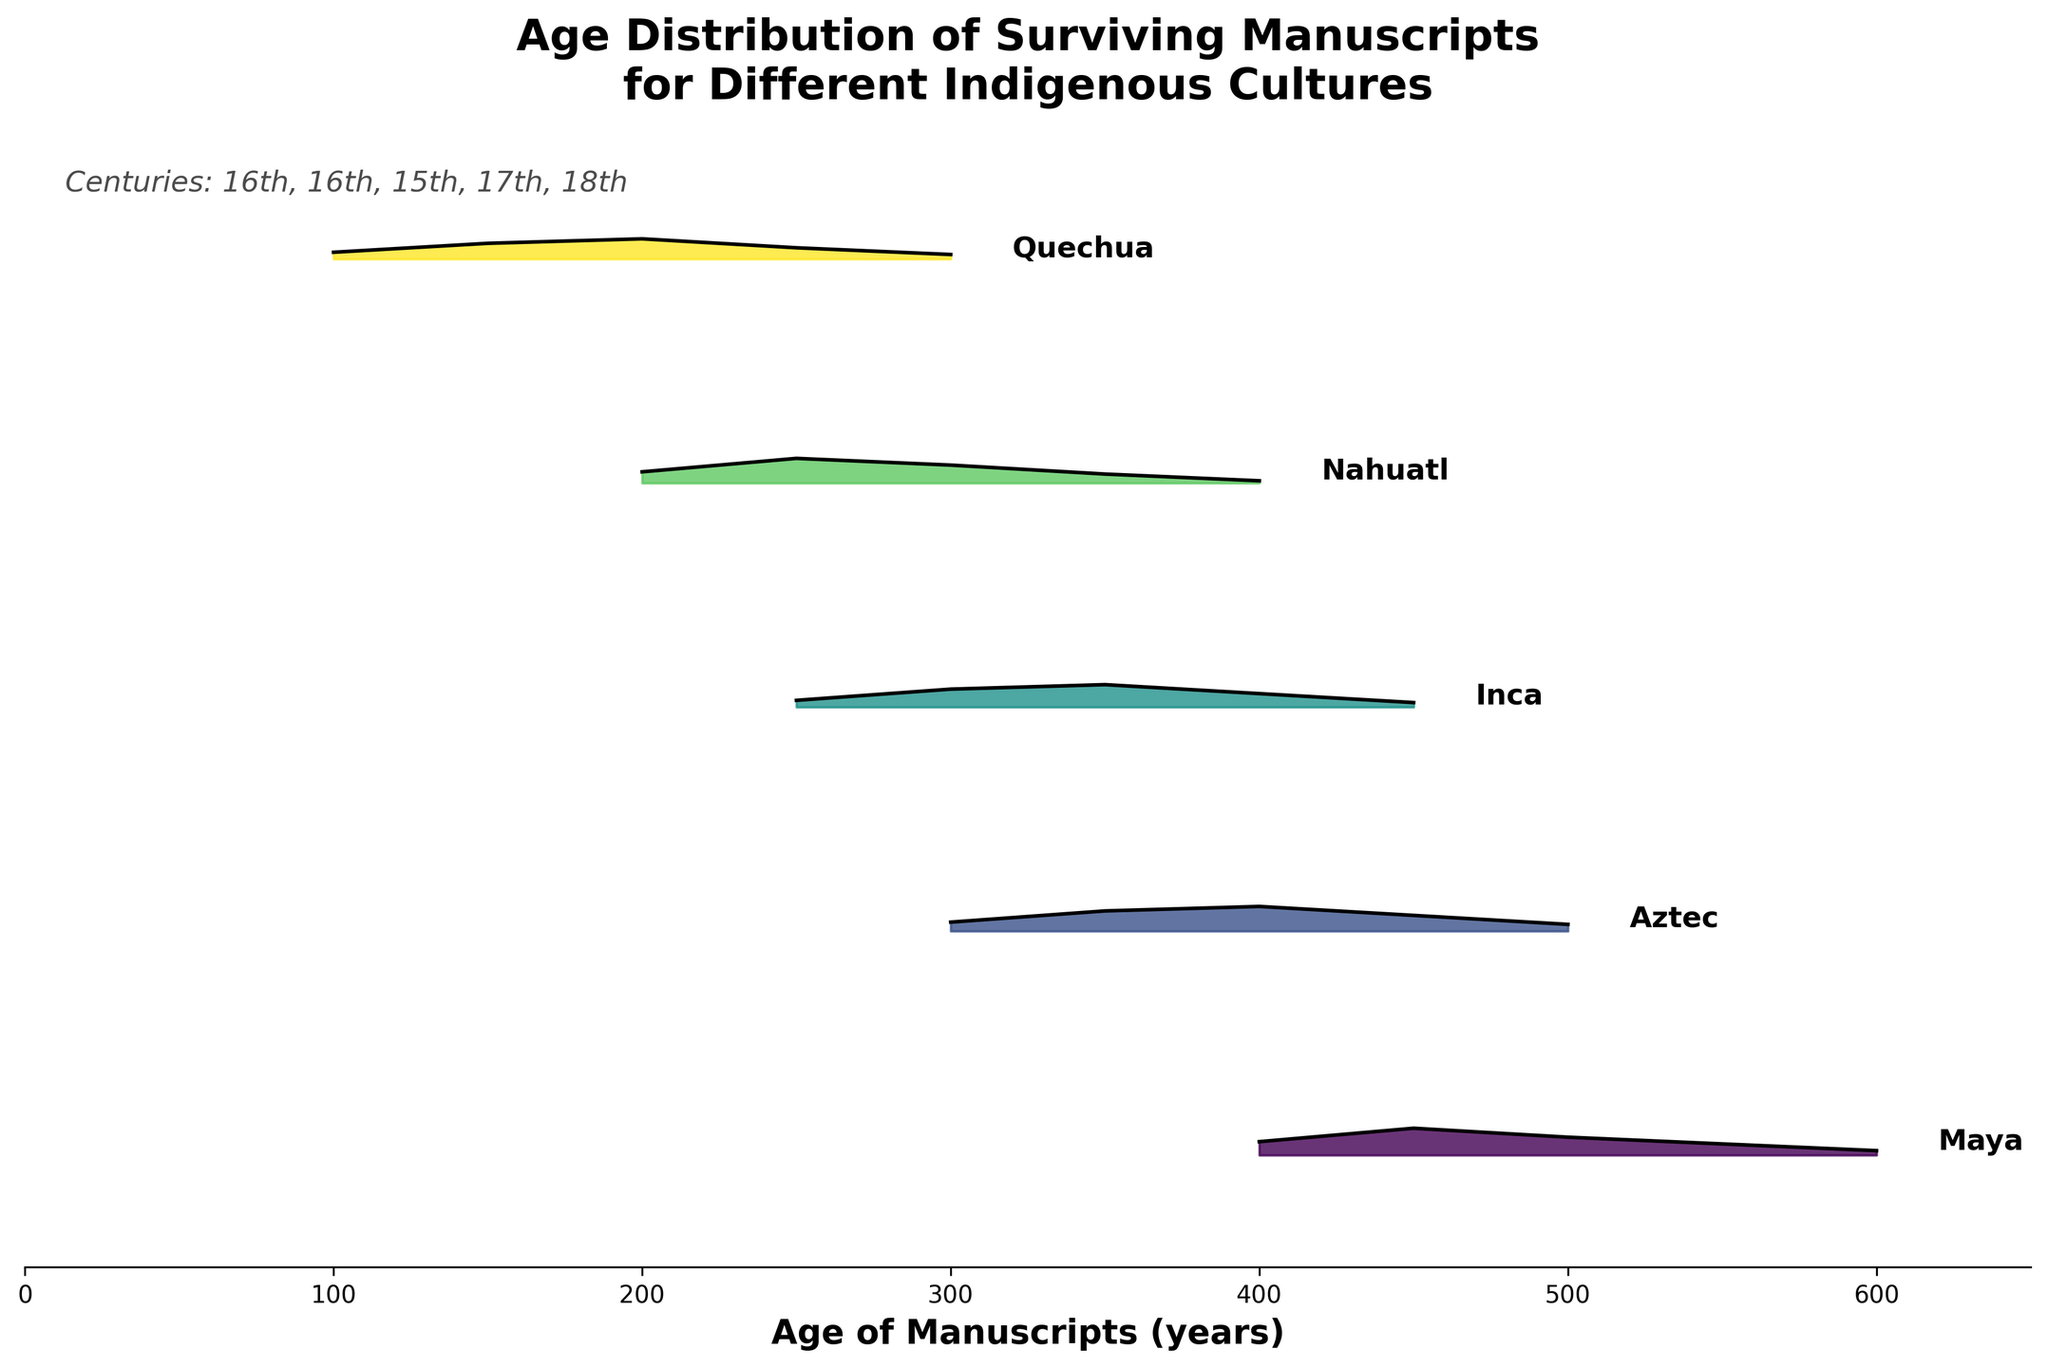What is the title of the figure? The title is located at the top center of the figure and prominently displays the main subject of the plot.
Answer: Age Distribution of Surviving Manuscripts for Different Indigenous Cultures Which culture has manuscripts with the greatest age, and what is that age? The Maya culture has manuscripts with the greatest age. This can be seen at the far right of the plot, where the Maya density curve extends furthest to the right.
Answer: Maya, 600 years In which century do the surviving Aztec manuscripts belong? The century is annotated alongside the manuscript density curve for each culture. For the Aztec culture, the label indicates the 16th century.
Answer: 16th century Which culture has the highest density for manuscripts aged 250 years? To determine this, look for the highest point on the density curves at the 250-year mark along the x-axis. The curve for the Nahuatl culture reaches its highest density at this point.
Answer: Nahuatl How many cultures in the figure have their manuscripts dated in the 17th century? The centuries for different cultures are labeled next to the density curves. Only the Nahuatl culture has manuscripts dated in the 17th century.
Answer: One (Nahuatl) Which culture's manuscripts have the highest peak density, and what is the approximate density value at that peak? To find the highest peak, compare the maximum heights across all density curves. The Maya culture has the highest peak density at approximately 0.12.
Answer: Maya, 0.12 For the Quechua manuscripts, what is the general trend in density as the age increases? Observing the Quechua density curve from left to right, it initially rises and then falls. This indicates that there was a higher density of manuscripts around 200-250 years and a lower density for older manuscripts.
Answer: Generally decreases Comparing Maya and Inca manuscripts in the 16th century, which culture's manuscripts are younger on average? The Inca manuscripts have higher densities at younger ages (300-450 years) compared to the Maya manuscripts (400-600 years). This indicates that Inca manuscripts are younger on average in this plot.
Answer: Inca Which culture has the narrowest age range for surviving manuscripts, and what is that range? To determine this, observe the spread of the density curves for each culture. The Nahuatl culture has the narrowest age range, from 200 to 400 years.
Answer: Nahuatl, 200-400 years What can be inferred about the preservation of manuscripts over the centuries from this plot? The density curves indicate that more recent centuries tend to show higher densities and narrower ranges, suggesting better preservation or survival of more recent manuscripts. For example, Aztec and Inca (16th-century) manuscripts are denser in specific age ranges compared to older Maya manuscripts. A detailed comparison of the curves can show how preservation might have improved over time.
Answer: More recent manuscripts better preserved 